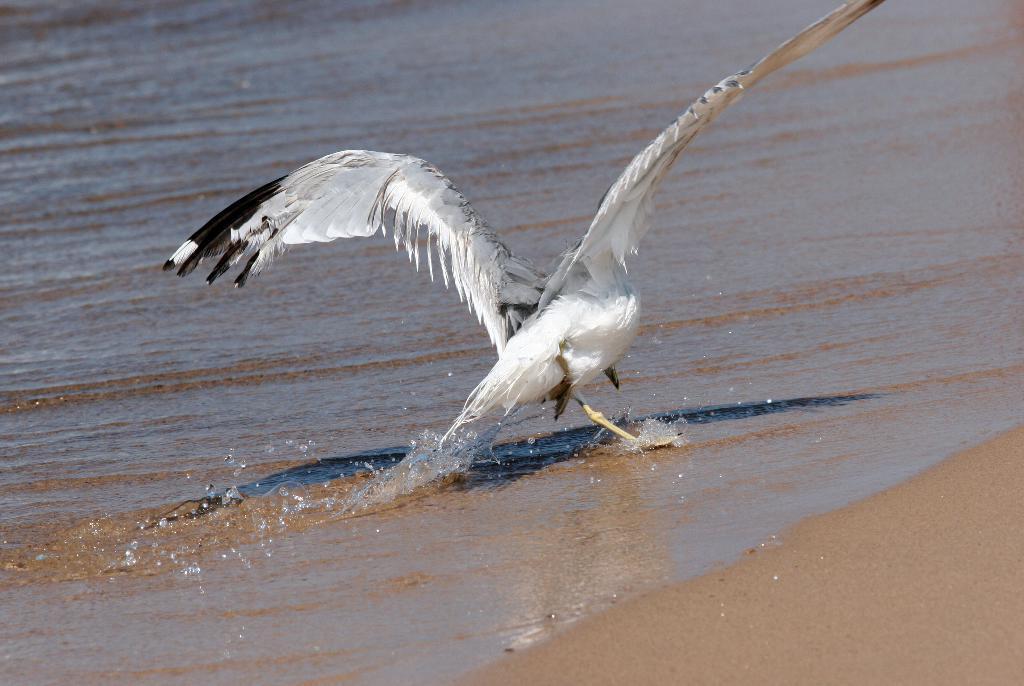How would you summarize this image in a sentence or two? In this image I can see the bird which is in white and black color. To the right I can see the sand. To the left I can see the water. 